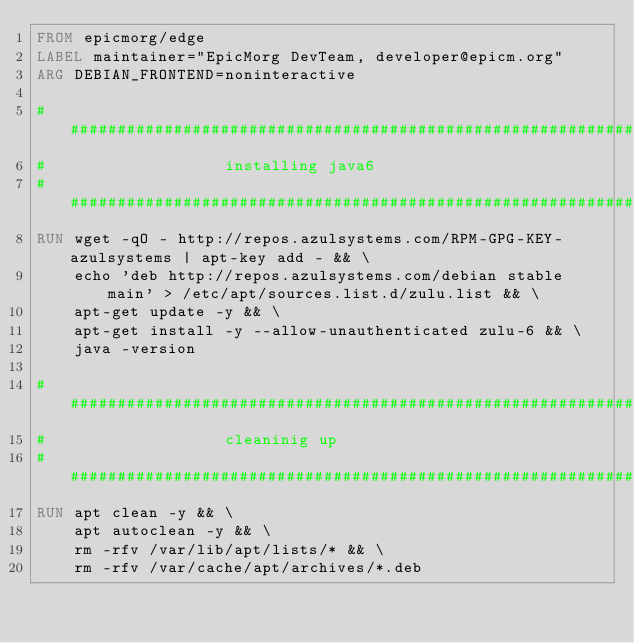<code> <loc_0><loc_0><loc_500><loc_500><_Dockerfile_>FROM epicmorg/edge
LABEL maintainer="EpicMorg DevTeam, developer@epicm.org"
ARG DEBIAN_FRONTEND=noninteractive

##################################################################
#                   installing java6
##################################################################
RUN wget -qO - http://repos.azulsystems.com/RPM-GPG-KEY-azulsystems | apt-key add - && \
    echo 'deb http://repos.azulsystems.com/debian stable main' > /etc/apt/sources.list.d/zulu.list && \
    apt-get update -y && \
    apt-get install -y --allow-unauthenticated zulu-6 && \
    java -version

##################################################################
#                   cleaninig up
##################################################################
RUN apt clean -y && \
    apt autoclean -y && \
    rm -rfv /var/lib/apt/lists/* && \
    rm -rfv /var/cache/apt/archives/*.deb
</code> 